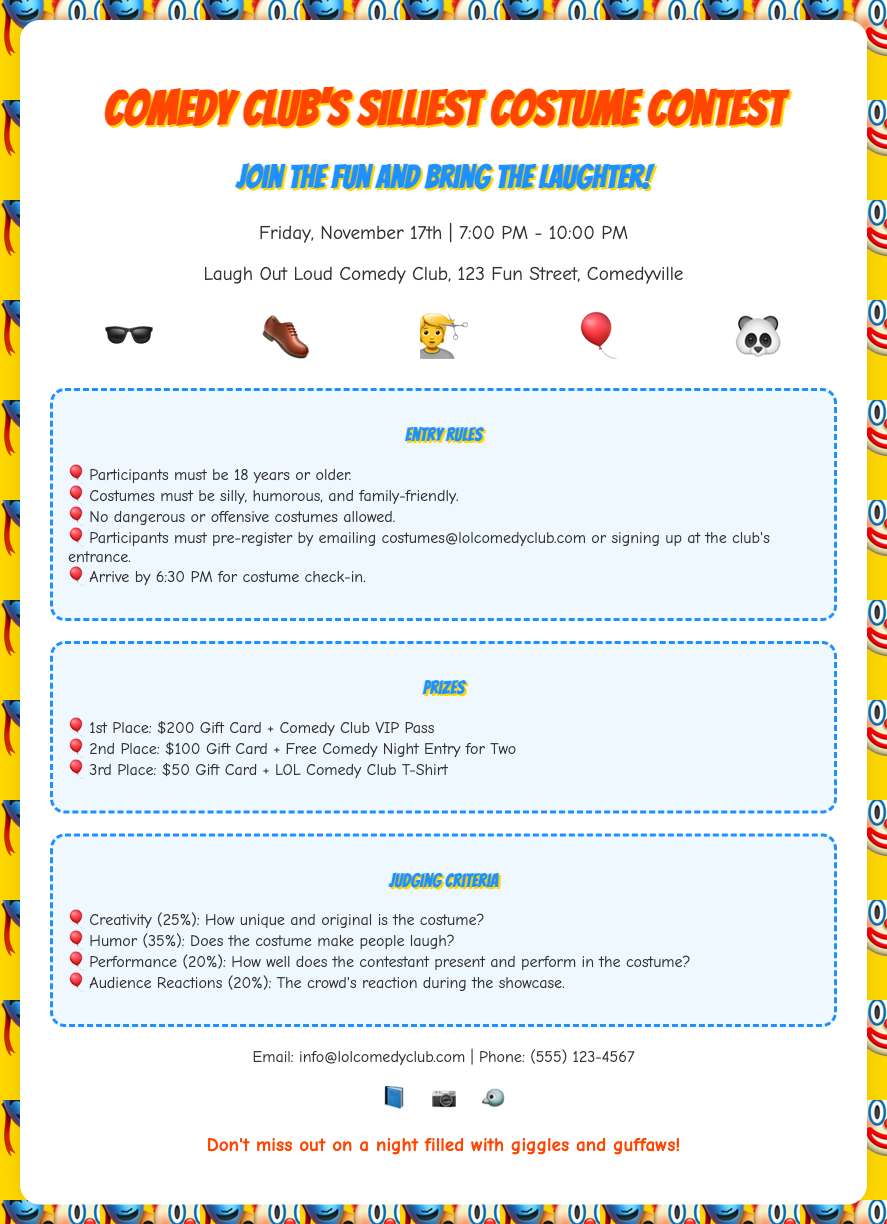What is the date of the contest? The contest is scheduled for Friday, November 17th.
Answer: November 17th What time does the contest start? The contest starts at 7:00 PM.
Answer: 7:00 PM What is the location of the event? The event takes place at Laugh Out Loud Comedy Club, 123 Fun Street, Comedyville.
Answer: Laugh Out Loud Comedy Club, 123 Fun Street, Comedyville How old must participants be? Participants are required to be at least 18 years old.
Answer: 18 years What is the prize for 1st place? The prize for 1st place is a $200 Gift Card and a Comedy Club VIP Pass.
Answer: $200 Gift Card + Comedy Club VIP Pass What percentage of the judging criteria is based on humor? Humor accounts for 35% of the judging criteria.
Answer: 35% What is a requirement for costumes? Costumes must be silly, humorous, and family-friendly.
Answer: Silly, humorous, and family-friendly By what time should participants arrive for costume check-in? Participants must arrive by 6:30 PM for costume check-in.
Answer: 6:30 PM How should participants pre-register? Participants can pre-register by emailing or signing up at the club's entrance.
Answer: Emailing or signing up at the entrance 